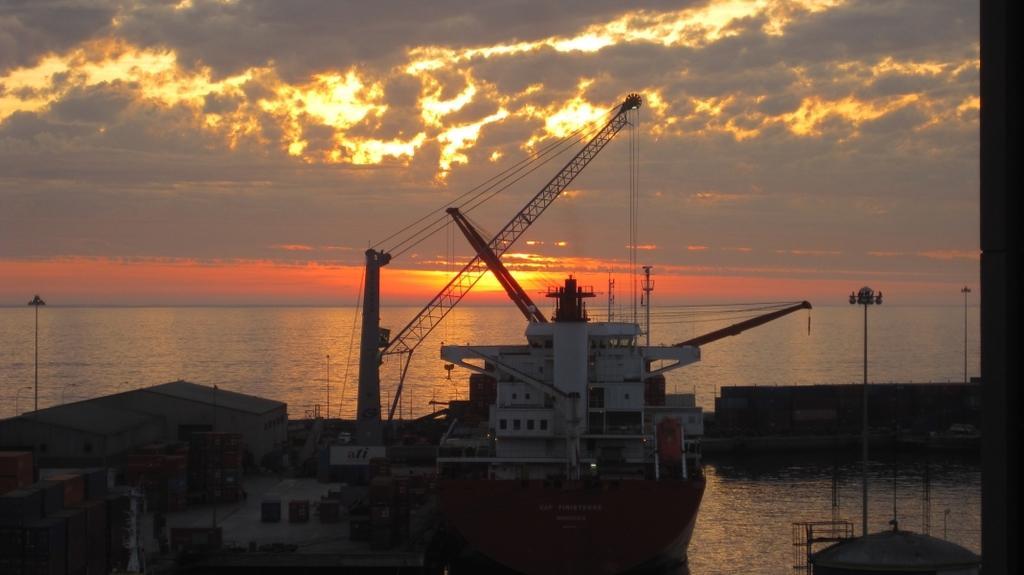Please provide a concise description of this image. In this image we can see boat station in which we can see containers, house and few more things. Here we can see a ship floating on the water, crane, ropes, poles here. in the background, we can see water, cloudy sky and sun rays. 